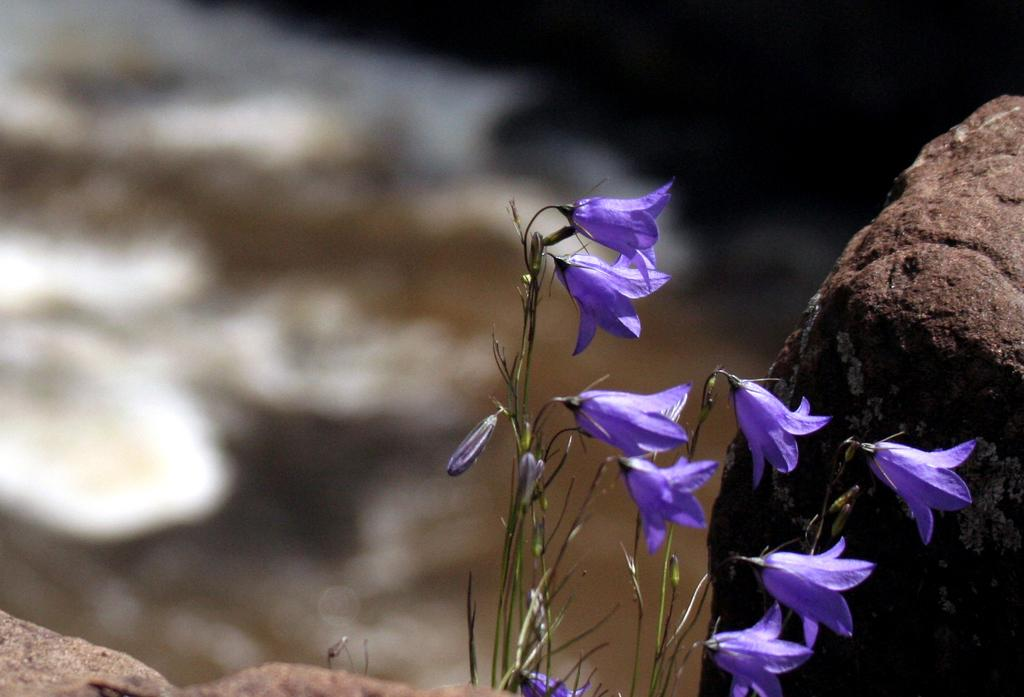What type of plants can be seen in the image? There are flowers in the image. What object is located on the right side of the image? There is a rock on the right side of the image. What type of government is depicted in the image? There is no government depicted in the image; it features flowers and a rock. What instrument is being played in the image? There is no instrument or music-related activity depicted in the image. 